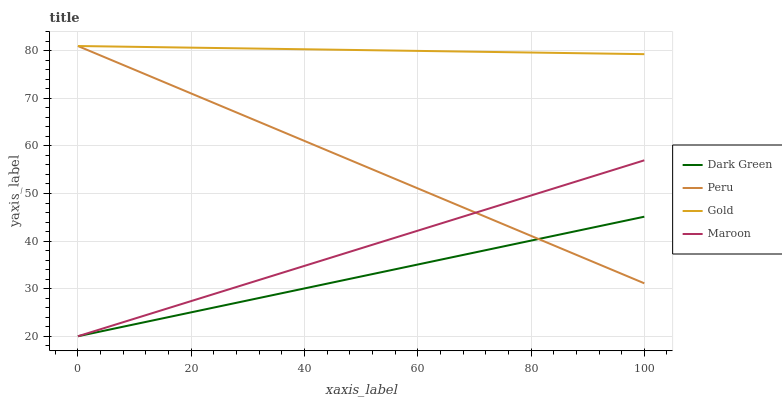Does Dark Green have the minimum area under the curve?
Answer yes or no. Yes. Does Gold have the maximum area under the curve?
Answer yes or no. Yes. Does Peru have the minimum area under the curve?
Answer yes or no. No. Does Peru have the maximum area under the curve?
Answer yes or no. No. Is Maroon the smoothest?
Answer yes or no. Yes. Is Peru the roughest?
Answer yes or no. Yes. Is Gold the smoothest?
Answer yes or no. No. Is Gold the roughest?
Answer yes or no. No. Does Maroon have the lowest value?
Answer yes or no. Yes. Does Peru have the lowest value?
Answer yes or no. No. Does Peru have the highest value?
Answer yes or no. Yes. Does Dark Green have the highest value?
Answer yes or no. No. Is Dark Green less than Gold?
Answer yes or no. Yes. Is Gold greater than Dark Green?
Answer yes or no. Yes. Does Dark Green intersect Peru?
Answer yes or no. Yes. Is Dark Green less than Peru?
Answer yes or no. No. Is Dark Green greater than Peru?
Answer yes or no. No. Does Dark Green intersect Gold?
Answer yes or no. No. 